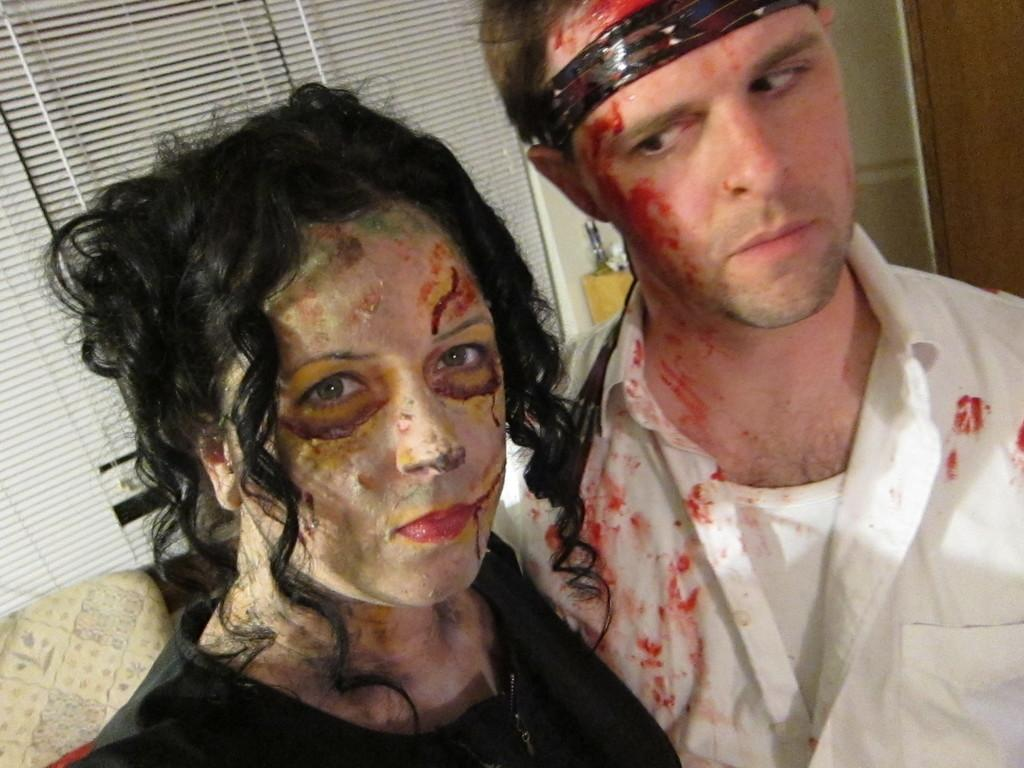What types of people are in the image? There are men and women in the image. What is the man wearing? The man is wearing a white color shirt. What is the woman wearing? The woman is wearing a black color dress. What can be seen in the background of the image? There is a sofa, a wall, and a window in the background of the image. How does the truck compare to the sofa in the image? There is no truck present in the image, so it cannot be compared to the sofa. 